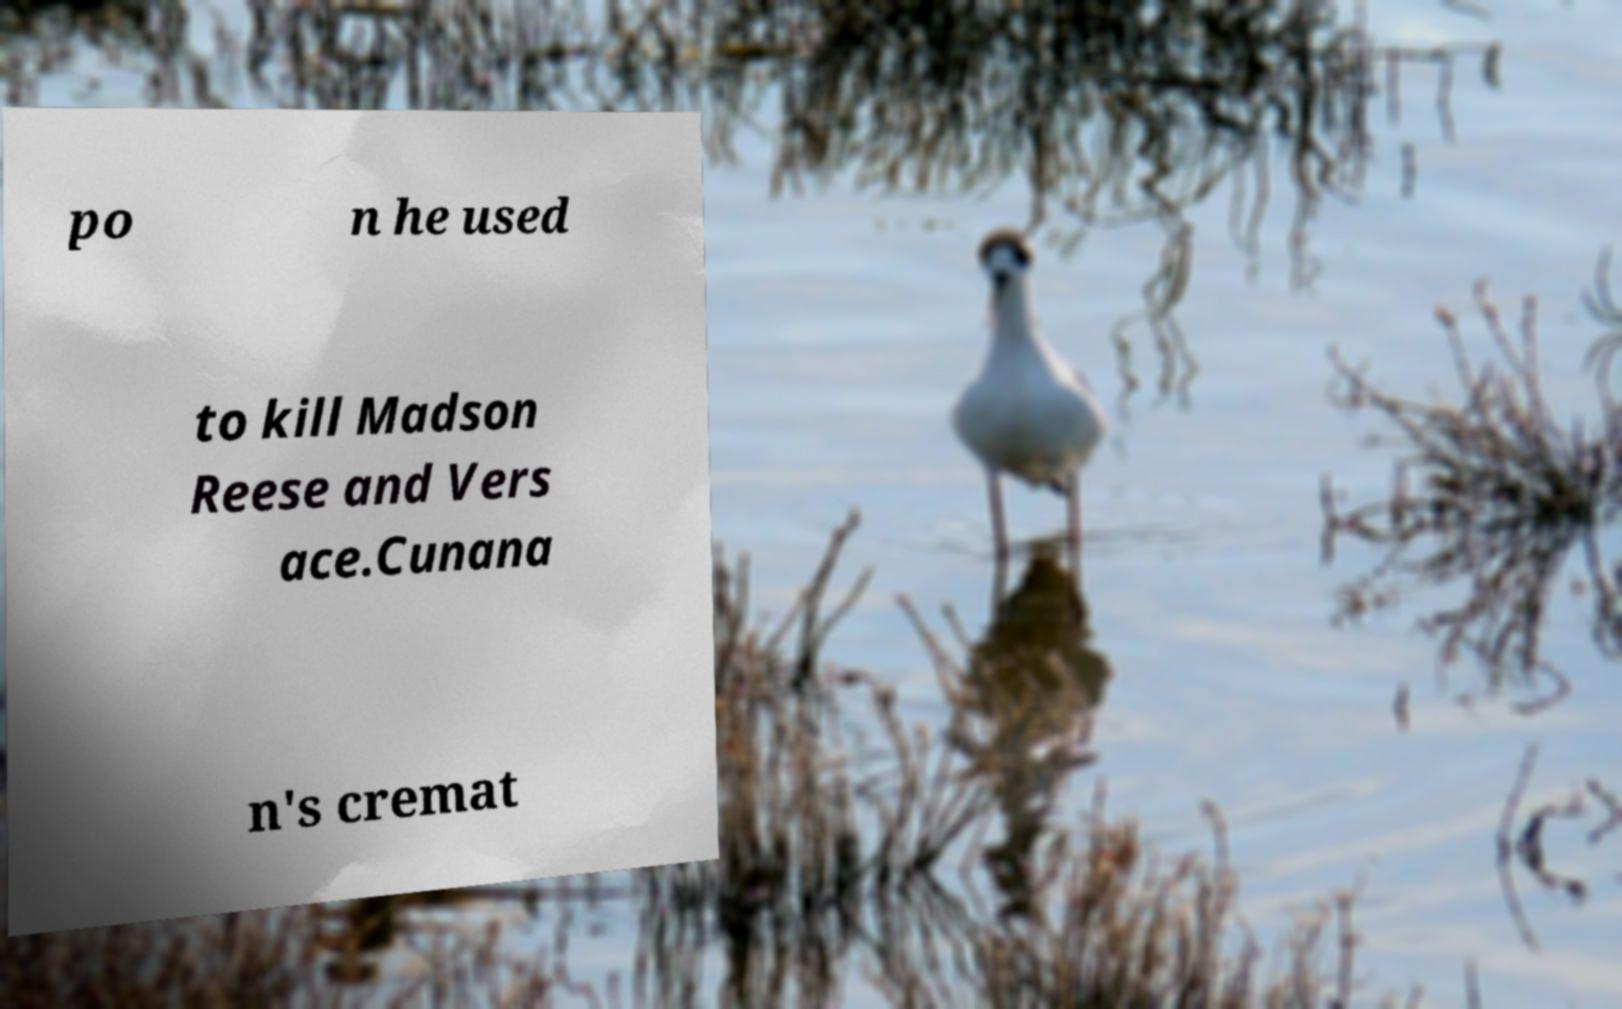What messages or text are displayed in this image? I need them in a readable, typed format. po n he used to kill Madson Reese and Vers ace.Cunana n's cremat 